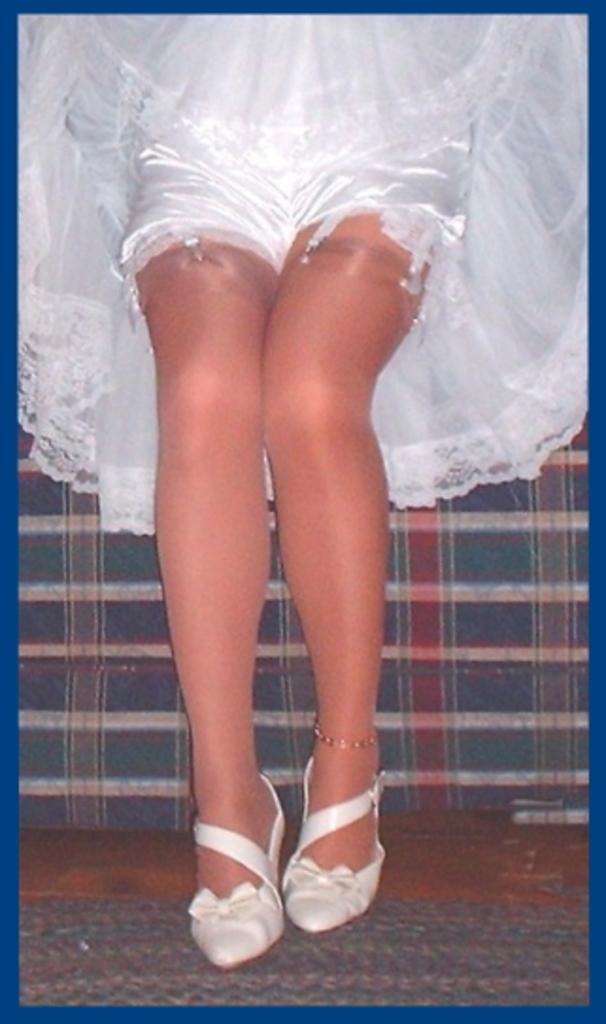In one or two sentences, can you explain what this image depicts? In this image we can see the legs of a woman, she is in white color dress. 